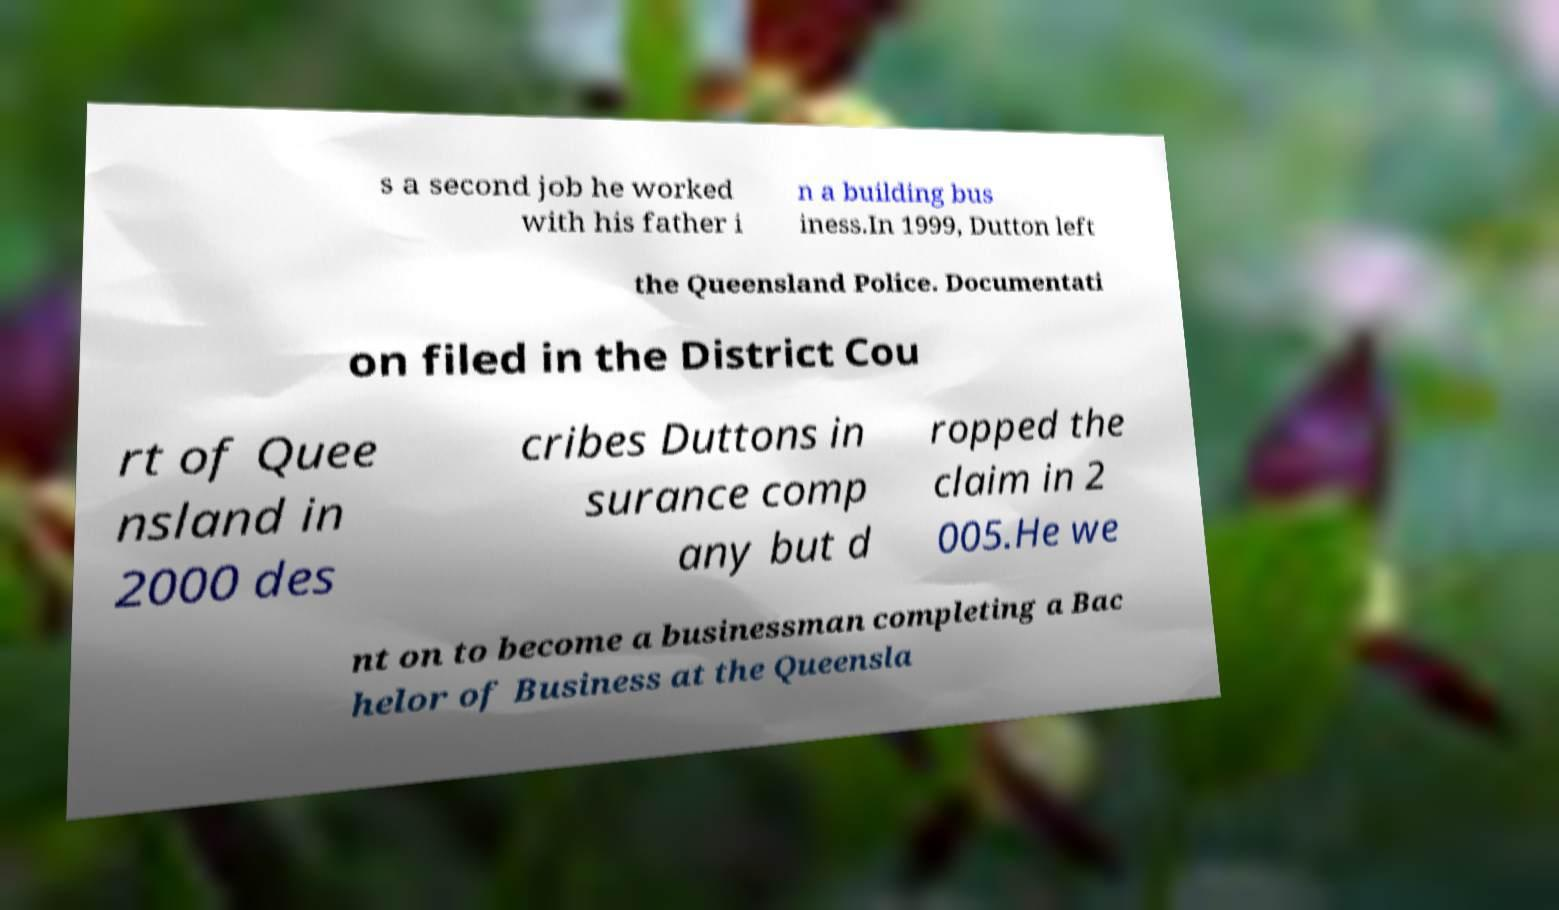Could you extract and type out the text from this image? s a second job he worked with his father i n a building bus iness.In 1999, Dutton left the Queensland Police. Documentati on filed in the District Cou rt of Quee nsland in 2000 des cribes Duttons in surance comp any but d ropped the claim in 2 005.He we nt on to become a businessman completing a Bac helor of Business at the Queensla 